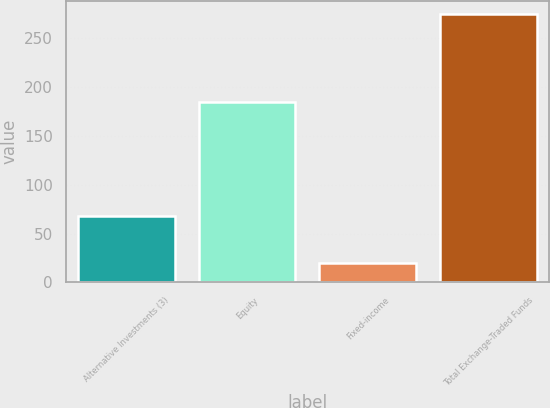Convert chart to OTSL. <chart><loc_0><loc_0><loc_500><loc_500><bar_chart><fcel>Alternative Investments (3)<fcel>Equity<fcel>Fixed-income<fcel>Total Exchange-Traded Funds<nl><fcel>68<fcel>184<fcel>20<fcel>274<nl></chart> 